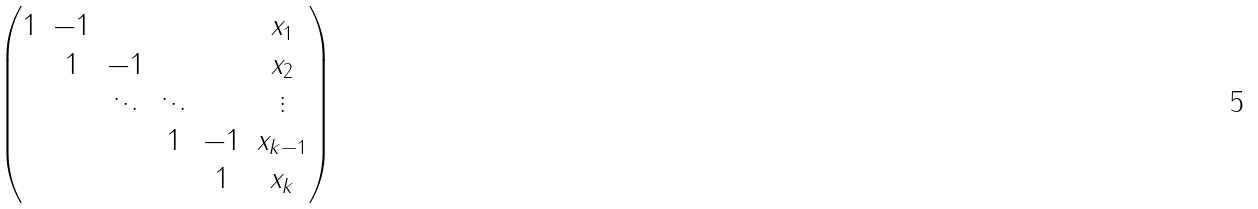<formula> <loc_0><loc_0><loc_500><loc_500>\left ( \begin{matrix} 1 & - 1 & & & & x _ { 1 } \\ & 1 & - 1 & & & x _ { 2 } \\ & & \ddots & \ddots & & \vdots \\ & & & 1 & - 1 & x _ { k - 1 } \\ & & & & 1 & x _ { k } \end{matrix} \right )</formula> 